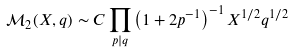Convert formula to latex. <formula><loc_0><loc_0><loc_500><loc_500>\mathcal { M } _ { 2 } ( X , q ) \sim C \prod _ { p | q } \left ( 1 + 2 p ^ { - 1 } \right ) ^ { - 1 } X ^ { 1 / 2 } q ^ { 1 / 2 }</formula> 